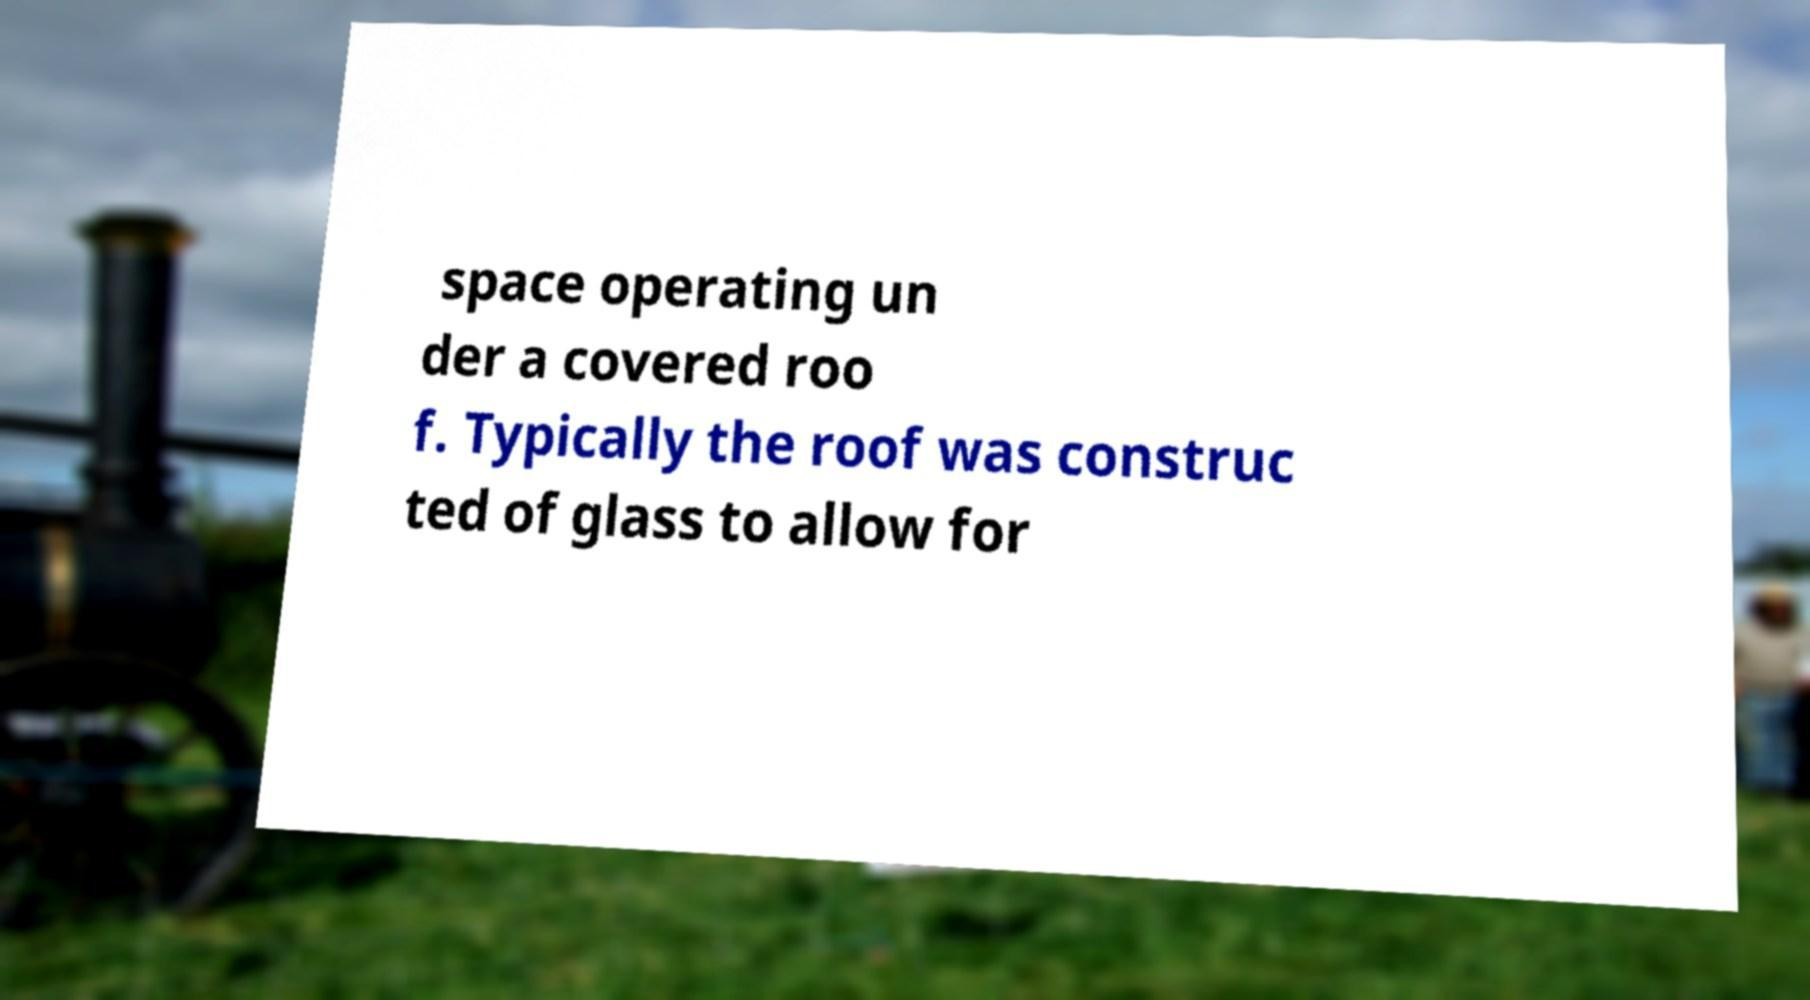There's text embedded in this image that I need extracted. Can you transcribe it verbatim? space operating un der a covered roo f. Typically the roof was construc ted of glass to allow for 